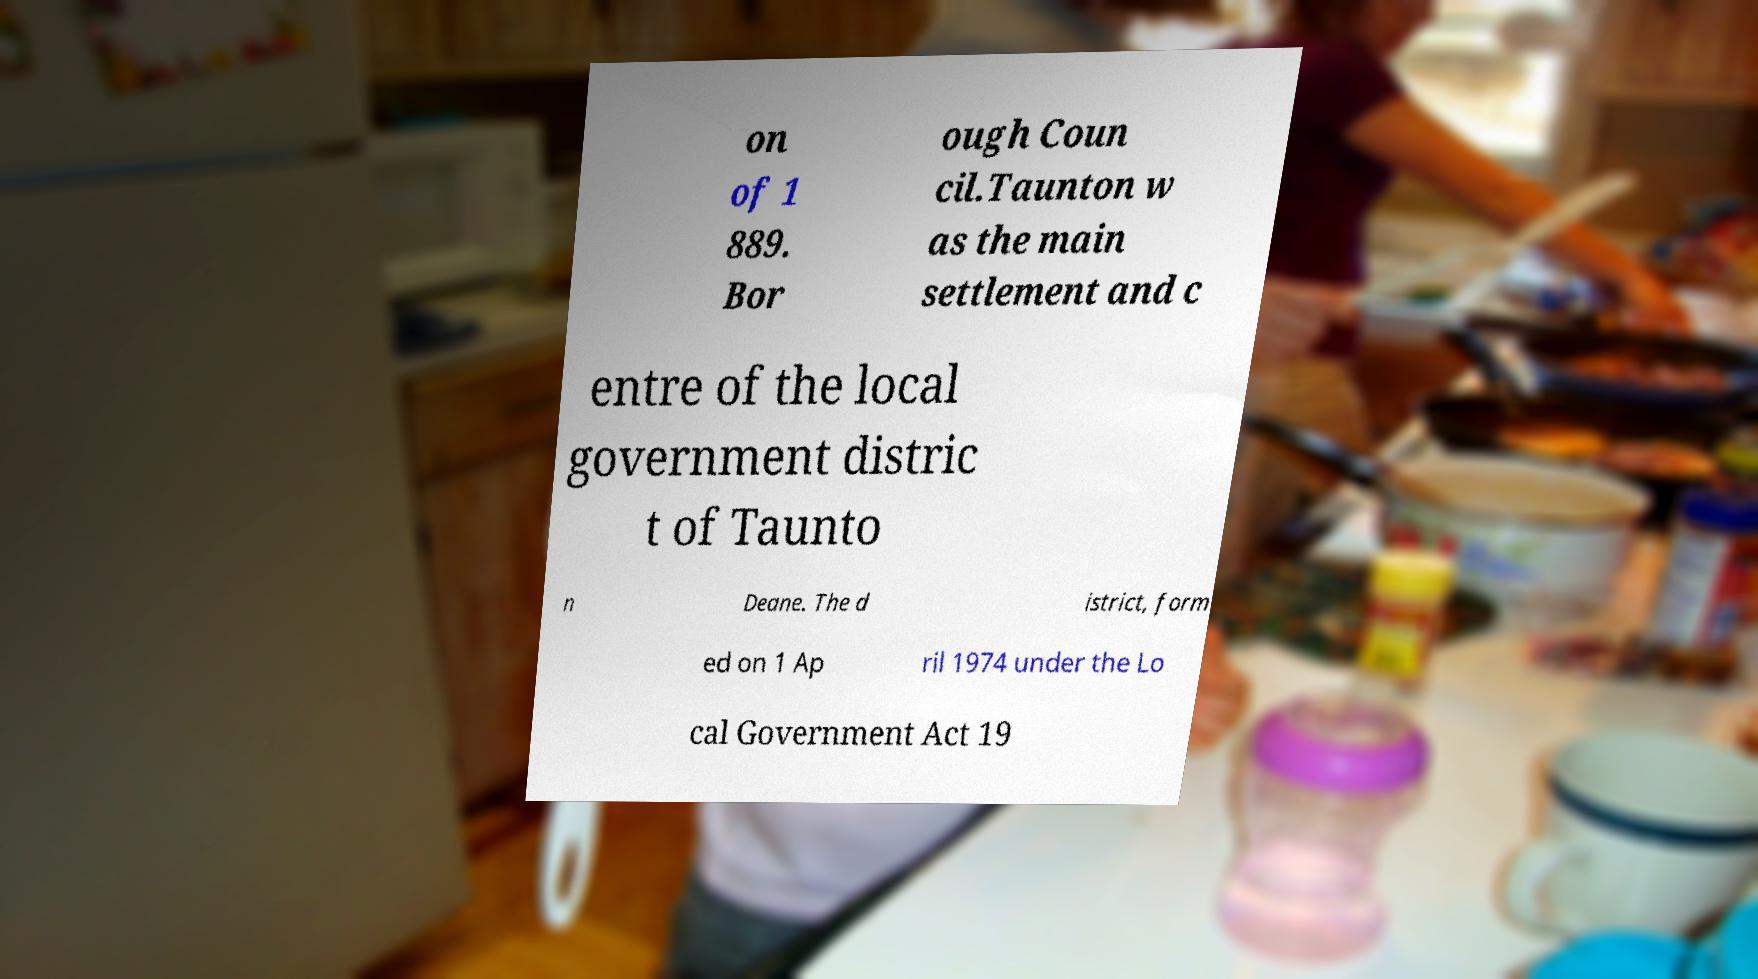Can you read and provide the text displayed in the image?This photo seems to have some interesting text. Can you extract and type it out for me? on of 1 889. Bor ough Coun cil.Taunton w as the main settlement and c entre of the local government distric t of Taunto n Deane. The d istrict, form ed on 1 Ap ril 1974 under the Lo cal Government Act 19 